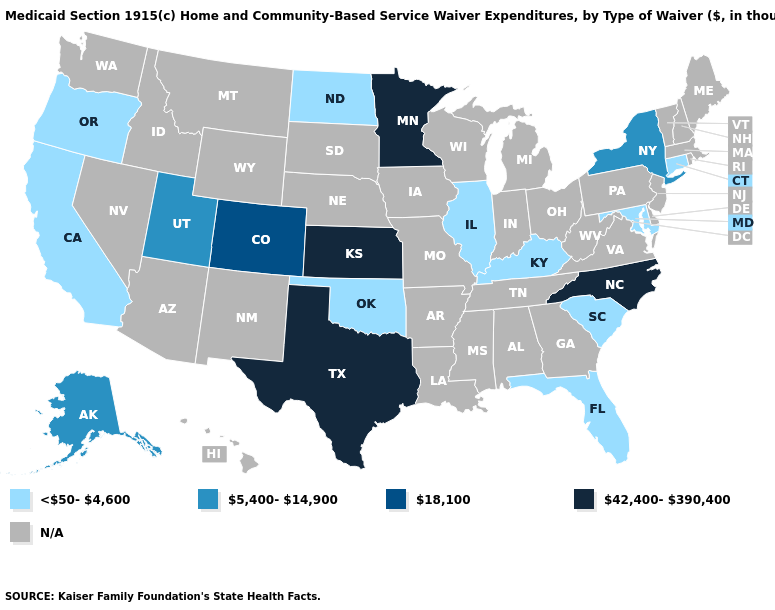What is the lowest value in the West?
Quick response, please. <50-4,600. Name the states that have a value in the range N/A?
Quick response, please. Alabama, Arizona, Arkansas, Delaware, Georgia, Hawaii, Idaho, Indiana, Iowa, Louisiana, Maine, Massachusetts, Michigan, Mississippi, Missouri, Montana, Nebraska, Nevada, New Hampshire, New Jersey, New Mexico, Ohio, Pennsylvania, Rhode Island, South Dakota, Tennessee, Vermont, Virginia, Washington, West Virginia, Wisconsin, Wyoming. Is the legend a continuous bar?
Concise answer only. No. What is the value of Oregon?
Give a very brief answer. <50-4,600. What is the highest value in states that border Iowa?
Quick response, please. 42,400-390,400. What is the value of Rhode Island?
Write a very short answer. N/A. What is the value of New Jersey?
Short answer required. N/A. What is the value of Virginia?
Be succinct. N/A. Which states hav the highest value in the Northeast?
Keep it brief. New York. Among the states that border New York , which have the highest value?
Write a very short answer. Connecticut. What is the value of Massachusetts?
Write a very short answer. N/A. What is the highest value in states that border Montana?
Be succinct. <50-4,600. Among the states that border New York , which have the lowest value?
Keep it brief. Connecticut. 